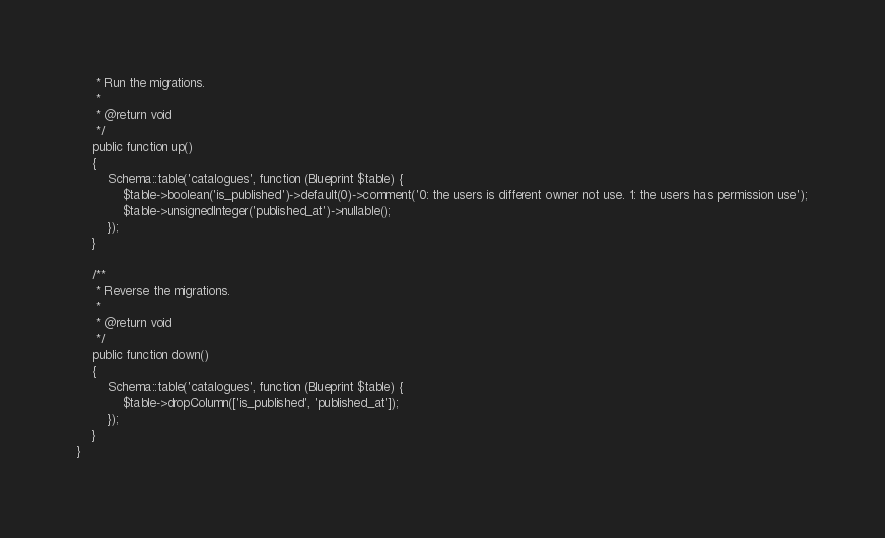Convert code to text. <code><loc_0><loc_0><loc_500><loc_500><_PHP_>     * Run the migrations.
     *
     * @return void
     */
    public function up()
    {
        Schema::table('catalogues', function (Blueprint $table) {
            $table->boolean('is_published')->default(0)->comment('0: the users is different owner not use. 1: the users has permission use');
            $table->unsignedInteger('published_at')->nullable();
        });
    }

    /**
     * Reverse the migrations.
     *
     * @return void
     */
    public function down()
    {
        Schema::table('catalogues', function (Blueprint $table) {
            $table->dropColumn(['is_published', 'published_at']);
        });
    }
}
</code> 